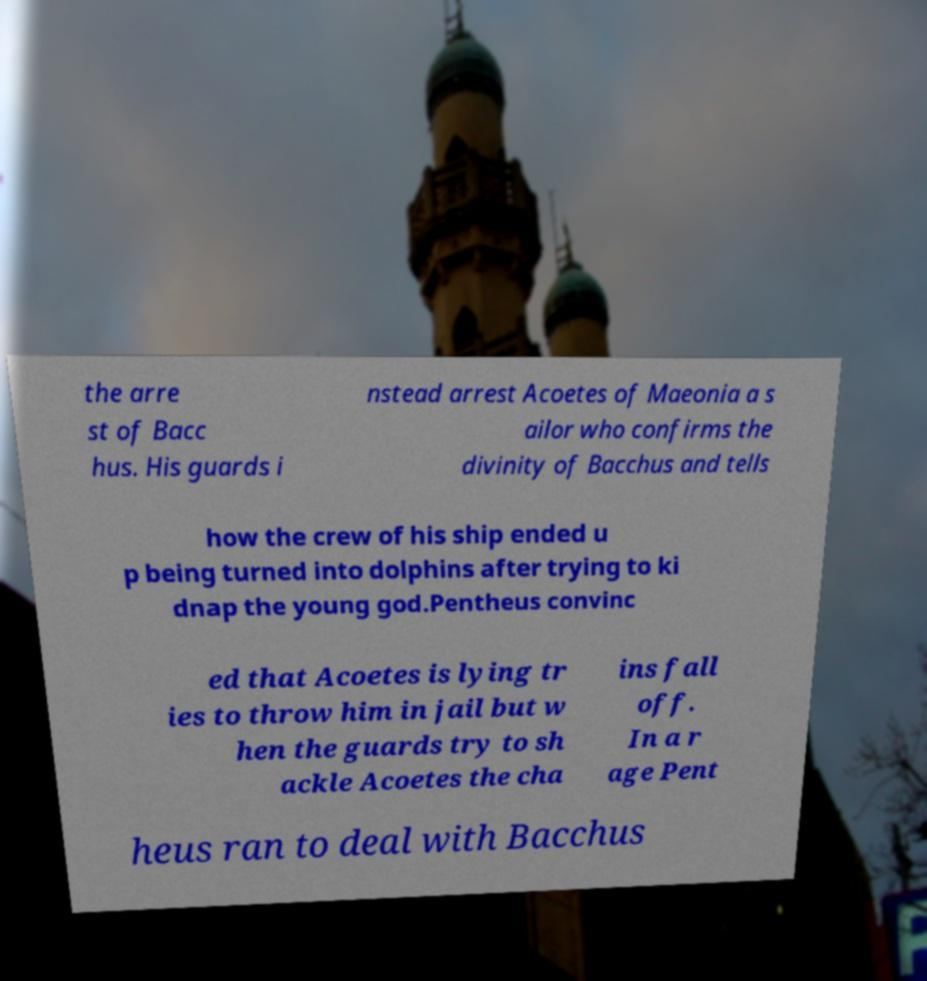Please identify and transcribe the text found in this image. the arre st of Bacc hus. His guards i nstead arrest Acoetes of Maeonia a s ailor who confirms the divinity of Bacchus and tells how the crew of his ship ended u p being turned into dolphins after trying to ki dnap the young god.Pentheus convinc ed that Acoetes is lying tr ies to throw him in jail but w hen the guards try to sh ackle Acoetes the cha ins fall off. In a r age Pent heus ran to deal with Bacchus 